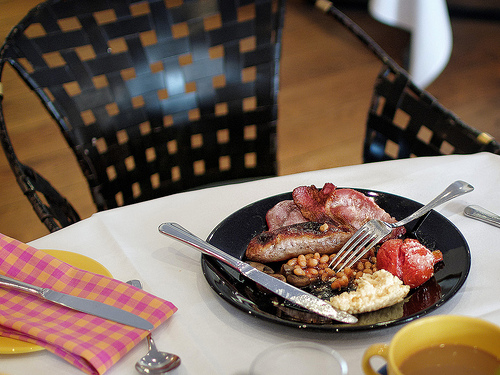<image>
Can you confirm if the plate is in front of the knife? No. The plate is not in front of the knife. The spatial positioning shows a different relationship between these objects. 